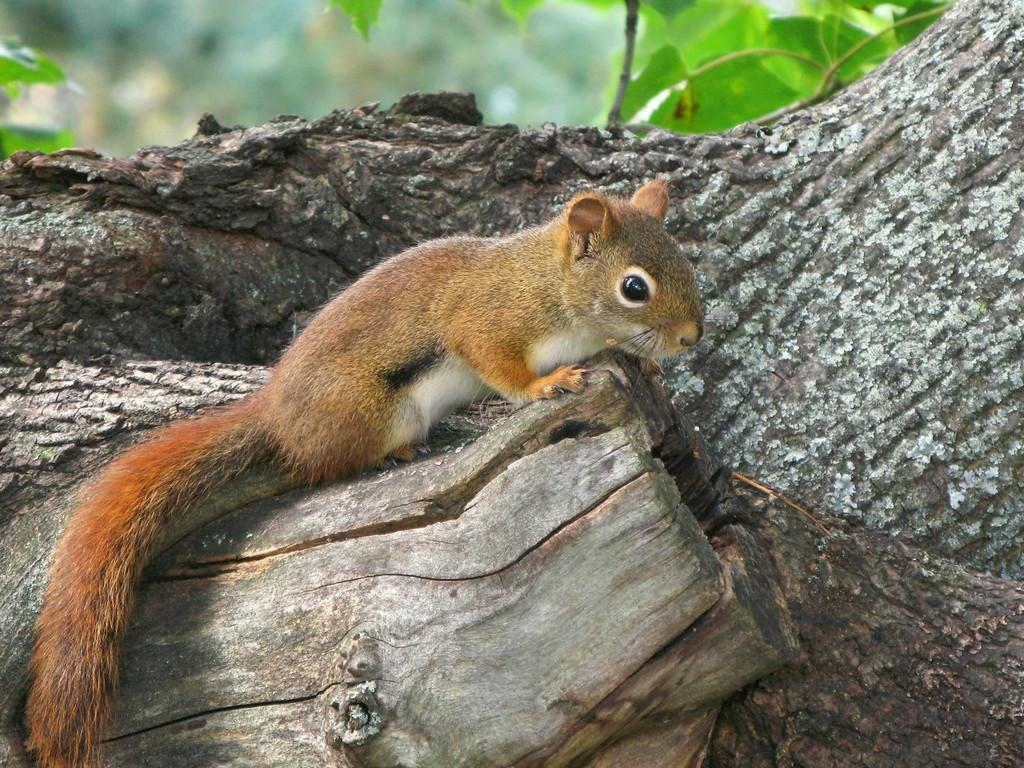Describe this image in one or two sentences. In the picture I can see a brown color squirrel standing on the tree trunk. Here I can see the leaves and the background of the image is slightly blurred. 